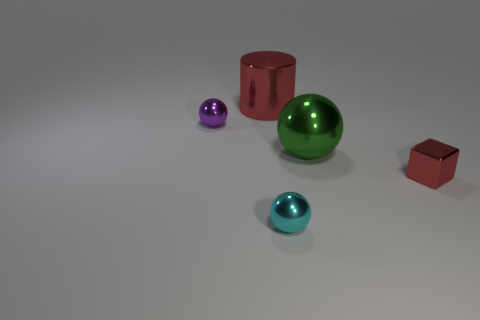Subtract all tiny cyan balls. How many balls are left? 2 Add 1 large green metal things. How many objects exist? 6 Subtract all purple balls. How many balls are left? 2 Subtract all spheres. How many objects are left? 2 Subtract 0 gray balls. How many objects are left? 5 Subtract all purple spheres. Subtract all gray cylinders. How many spheres are left? 2 Subtract all green rubber cylinders. Subtract all cylinders. How many objects are left? 4 Add 2 metallic cylinders. How many metallic cylinders are left? 3 Add 2 green rubber objects. How many green rubber objects exist? 2 